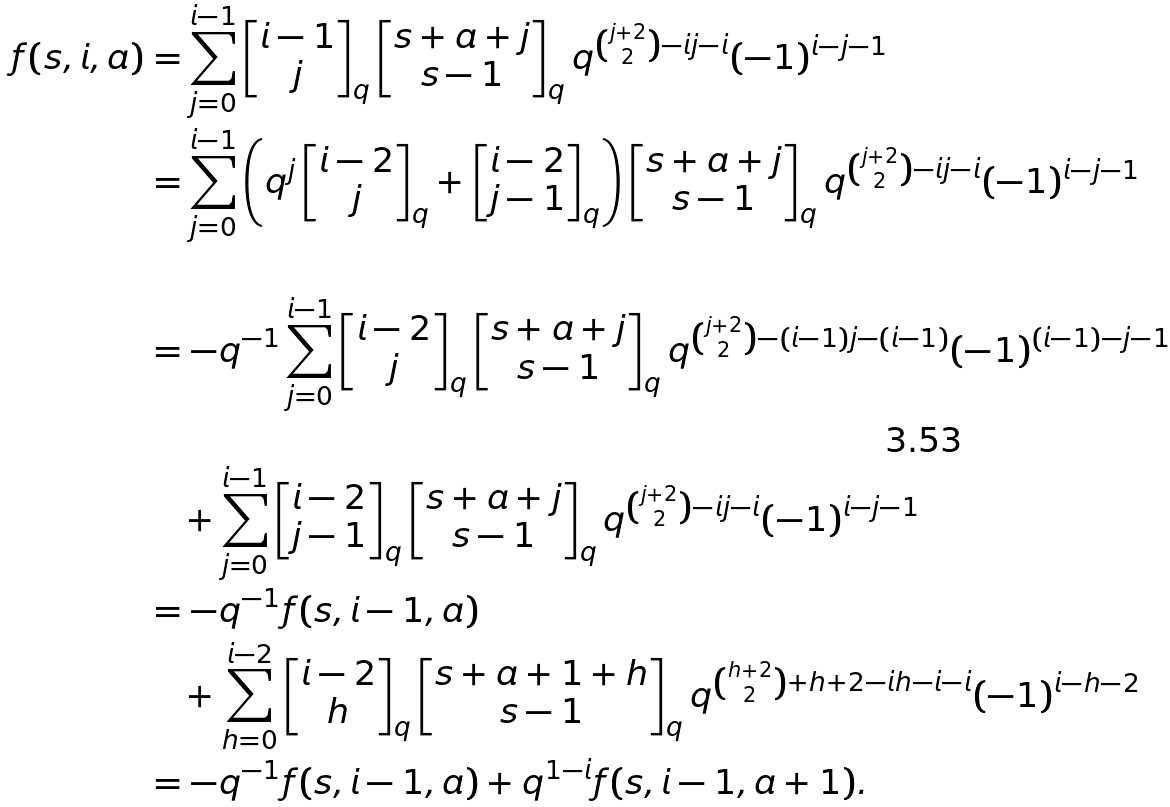<formula> <loc_0><loc_0><loc_500><loc_500>f ( s , i , a ) & = \sum _ { j = 0 } ^ { i - 1 } \begin{bmatrix} i - 1 \\ j \end{bmatrix} _ { q } \begin{bmatrix} s + a + j \\ s - 1 \end{bmatrix} _ { q } q ^ { \binom { j + 2 } { 2 } - i j - i } ( - 1 ) ^ { i - j - 1 } \\ & = \sum _ { j = 0 } ^ { i - 1 } \left ( q ^ { j } \begin{bmatrix} i - 2 \\ j \end{bmatrix} _ { q } + \begin{bmatrix} i - 2 \\ j - 1 \end{bmatrix} _ { q } \right ) \begin{bmatrix} s + a + j \\ s - 1 \end{bmatrix} _ { q } q ^ { \binom { j + 2 } { 2 } - i j - i } ( - 1 ) ^ { i - j - 1 } \\ \\ & = - q ^ { - 1 } \sum _ { j = 0 } ^ { i - 1 } \begin{bmatrix} i - 2 \\ j \end{bmatrix} _ { q } \begin{bmatrix} s + a + j \\ s - 1 \end{bmatrix} _ { q } q ^ { \binom { j + 2 } { 2 } - ( i - 1 ) j - ( i - 1 ) } ( - 1 ) ^ { ( i - 1 ) - j - 1 } \\ \\ & \quad + \sum _ { j = 0 } ^ { i - 1 } \begin{bmatrix} i - 2 \\ j - 1 \end{bmatrix} _ { q } \begin{bmatrix} s + a + j \\ s - 1 \end{bmatrix} _ { q } q ^ { \binom { j + 2 } { 2 } - i j - i } ( - 1 ) ^ { i - j - 1 } \\ & = - q ^ { - 1 } f ( s , i - 1 , a ) \\ & \quad + \sum _ { h = 0 } ^ { i - 2 } \begin{bmatrix} i - 2 \\ h \end{bmatrix} _ { q } \begin{bmatrix} s + a + 1 + h \\ s - 1 \end{bmatrix} _ { q } q ^ { \binom { h + 2 } { 2 } + h + 2 - i h - i - i } ( - 1 ) ^ { i - h - 2 } \\ & = - q ^ { - 1 } f ( s , i - 1 , a ) + q ^ { 1 - i } f ( s , i - 1 , a + 1 ) .</formula> 